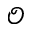<formula> <loc_0><loc_0><loc_500><loc_500>\mathcal { O }</formula> 